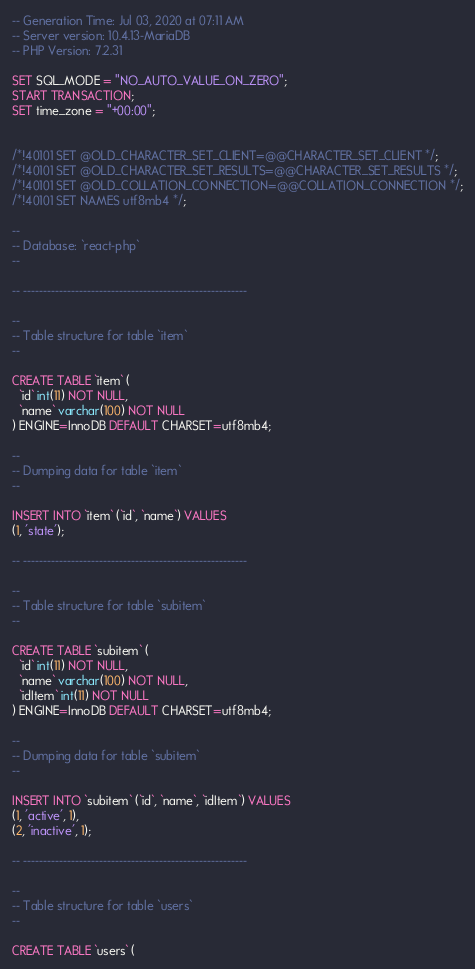Convert code to text. <code><loc_0><loc_0><loc_500><loc_500><_SQL_>-- Generation Time: Jul 03, 2020 at 07:11 AM
-- Server version: 10.4.13-MariaDB
-- PHP Version: 7.2.31

SET SQL_MODE = "NO_AUTO_VALUE_ON_ZERO";
START TRANSACTION;
SET time_zone = "+00:00";


/*!40101 SET @OLD_CHARACTER_SET_CLIENT=@@CHARACTER_SET_CLIENT */;
/*!40101 SET @OLD_CHARACTER_SET_RESULTS=@@CHARACTER_SET_RESULTS */;
/*!40101 SET @OLD_COLLATION_CONNECTION=@@COLLATION_CONNECTION */;
/*!40101 SET NAMES utf8mb4 */;

--
-- Database: `react-php`
--

-- --------------------------------------------------------

--
-- Table structure for table `item`
--

CREATE TABLE `item` (
  `id` int(11) NOT NULL,
  `name` varchar(100) NOT NULL
) ENGINE=InnoDB DEFAULT CHARSET=utf8mb4;

--
-- Dumping data for table `item`
--

INSERT INTO `item` (`id`, `name`) VALUES
(1, 'state');

-- --------------------------------------------------------

--
-- Table structure for table `subitem`
--

CREATE TABLE `subitem` (
  `id` int(11) NOT NULL,
  `name` varchar(100) NOT NULL,
  `idItem` int(11) NOT NULL
) ENGINE=InnoDB DEFAULT CHARSET=utf8mb4;

--
-- Dumping data for table `subitem`
--

INSERT INTO `subitem` (`id`, `name`, `idItem`) VALUES
(1, 'active', 1),
(2, 'inactive', 1);

-- --------------------------------------------------------

--
-- Table structure for table `users`
--

CREATE TABLE `users` (</code> 